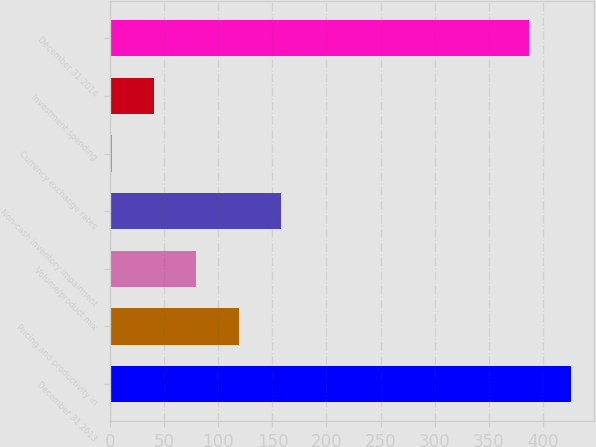Convert chart to OTSL. <chart><loc_0><loc_0><loc_500><loc_500><bar_chart><fcel>December 31 2013<fcel>Pricing and productivity in<fcel>Volume/product mix<fcel>Non-cash inventory impairment<fcel>Currency exchange rates<fcel>Investment spending<fcel>December 31 2014<nl><fcel>426.37<fcel>118.61<fcel>79.54<fcel>157.68<fcel>1.4<fcel>40.47<fcel>387.3<nl></chart> 